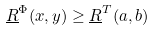<formula> <loc_0><loc_0><loc_500><loc_500>\underline { R } ^ { \Phi } ( x , y ) \geq \underline { R } ^ { T } ( a , b )</formula> 